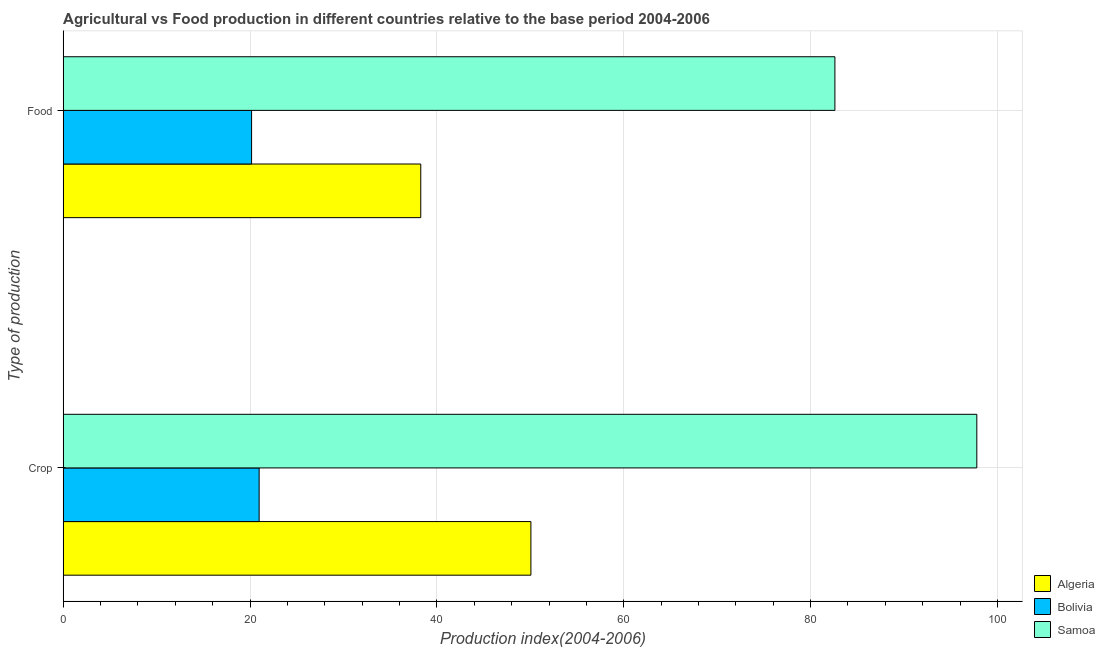How many different coloured bars are there?
Offer a very short reply. 3. How many groups of bars are there?
Your answer should be very brief. 2. Are the number of bars per tick equal to the number of legend labels?
Offer a very short reply. Yes. Are the number of bars on each tick of the Y-axis equal?
Your answer should be compact. Yes. How many bars are there on the 2nd tick from the bottom?
Your answer should be very brief. 3. What is the label of the 1st group of bars from the top?
Offer a very short reply. Food. What is the crop production index in Bolivia?
Provide a succinct answer. 20.97. Across all countries, what is the maximum food production index?
Provide a short and direct response. 82.6. Across all countries, what is the minimum food production index?
Offer a very short reply. 20.16. In which country was the food production index maximum?
Offer a terse response. Samoa. What is the total food production index in the graph?
Offer a very short reply. 141.03. What is the difference between the crop production index in Samoa and that in Bolivia?
Your answer should be compact. 76.82. What is the difference between the crop production index in Algeria and the food production index in Bolivia?
Your response must be concise. 29.9. What is the average food production index per country?
Provide a succinct answer. 47.01. What is the difference between the food production index and crop production index in Bolivia?
Provide a short and direct response. -0.81. What is the ratio of the food production index in Algeria to that in Samoa?
Your response must be concise. 0.46. Is the food production index in Samoa less than that in Algeria?
Offer a terse response. No. In how many countries, is the crop production index greater than the average crop production index taken over all countries?
Give a very brief answer. 1. What does the 1st bar from the top in Crop represents?
Your answer should be very brief. Samoa. What does the 1st bar from the bottom in Crop represents?
Offer a very short reply. Algeria. How many bars are there?
Your response must be concise. 6. How many countries are there in the graph?
Make the answer very short. 3. What is the difference between two consecutive major ticks on the X-axis?
Provide a succinct answer. 20. Where does the legend appear in the graph?
Your answer should be very brief. Bottom right. How many legend labels are there?
Give a very brief answer. 3. What is the title of the graph?
Offer a terse response. Agricultural vs Food production in different countries relative to the base period 2004-2006. Does "Greenland" appear as one of the legend labels in the graph?
Your answer should be very brief. No. What is the label or title of the X-axis?
Provide a short and direct response. Production index(2004-2006). What is the label or title of the Y-axis?
Your answer should be very brief. Type of production. What is the Production index(2004-2006) in Algeria in Crop?
Make the answer very short. 50.06. What is the Production index(2004-2006) of Bolivia in Crop?
Provide a short and direct response. 20.97. What is the Production index(2004-2006) in Samoa in Crop?
Keep it short and to the point. 97.79. What is the Production index(2004-2006) of Algeria in Food?
Your response must be concise. 38.27. What is the Production index(2004-2006) of Bolivia in Food?
Ensure brevity in your answer.  20.16. What is the Production index(2004-2006) of Samoa in Food?
Offer a terse response. 82.6. Across all Type of production, what is the maximum Production index(2004-2006) of Algeria?
Offer a very short reply. 50.06. Across all Type of production, what is the maximum Production index(2004-2006) of Bolivia?
Offer a terse response. 20.97. Across all Type of production, what is the maximum Production index(2004-2006) in Samoa?
Make the answer very short. 97.79. Across all Type of production, what is the minimum Production index(2004-2006) of Algeria?
Your answer should be very brief. 38.27. Across all Type of production, what is the minimum Production index(2004-2006) of Bolivia?
Offer a terse response. 20.16. Across all Type of production, what is the minimum Production index(2004-2006) in Samoa?
Ensure brevity in your answer.  82.6. What is the total Production index(2004-2006) of Algeria in the graph?
Offer a very short reply. 88.33. What is the total Production index(2004-2006) of Bolivia in the graph?
Give a very brief answer. 41.13. What is the total Production index(2004-2006) of Samoa in the graph?
Ensure brevity in your answer.  180.39. What is the difference between the Production index(2004-2006) in Algeria in Crop and that in Food?
Your response must be concise. 11.79. What is the difference between the Production index(2004-2006) of Bolivia in Crop and that in Food?
Ensure brevity in your answer.  0.81. What is the difference between the Production index(2004-2006) of Samoa in Crop and that in Food?
Your answer should be very brief. 15.19. What is the difference between the Production index(2004-2006) of Algeria in Crop and the Production index(2004-2006) of Bolivia in Food?
Make the answer very short. 29.9. What is the difference between the Production index(2004-2006) of Algeria in Crop and the Production index(2004-2006) of Samoa in Food?
Provide a succinct answer. -32.54. What is the difference between the Production index(2004-2006) of Bolivia in Crop and the Production index(2004-2006) of Samoa in Food?
Your answer should be compact. -61.63. What is the average Production index(2004-2006) of Algeria per Type of production?
Keep it short and to the point. 44.16. What is the average Production index(2004-2006) in Bolivia per Type of production?
Your answer should be compact. 20.57. What is the average Production index(2004-2006) of Samoa per Type of production?
Provide a succinct answer. 90.19. What is the difference between the Production index(2004-2006) of Algeria and Production index(2004-2006) of Bolivia in Crop?
Provide a succinct answer. 29.09. What is the difference between the Production index(2004-2006) of Algeria and Production index(2004-2006) of Samoa in Crop?
Keep it short and to the point. -47.73. What is the difference between the Production index(2004-2006) of Bolivia and Production index(2004-2006) of Samoa in Crop?
Make the answer very short. -76.82. What is the difference between the Production index(2004-2006) of Algeria and Production index(2004-2006) of Bolivia in Food?
Make the answer very short. 18.11. What is the difference between the Production index(2004-2006) of Algeria and Production index(2004-2006) of Samoa in Food?
Offer a terse response. -44.33. What is the difference between the Production index(2004-2006) in Bolivia and Production index(2004-2006) in Samoa in Food?
Make the answer very short. -62.44. What is the ratio of the Production index(2004-2006) of Algeria in Crop to that in Food?
Your answer should be very brief. 1.31. What is the ratio of the Production index(2004-2006) in Bolivia in Crop to that in Food?
Your response must be concise. 1.04. What is the ratio of the Production index(2004-2006) in Samoa in Crop to that in Food?
Offer a terse response. 1.18. What is the difference between the highest and the second highest Production index(2004-2006) of Algeria?
Keep it short and to the point. 11.79. What is the difference between the highest and the second highest Production index(2004-2006) in Bolivia?
Your response must be concise. 0.81. What is the difference between the highest and the second highest Production index(2004-2006) of Samoa?
Ensure brevity in your answer.  15.19. What is the difference between the highest and the lowest Production index(2004-2006) in Algeria?
Make the answer very short. 11.79. What is the difference between the highest and the lowest Production index(2004-2006) in Bolivia?
Offer a terse response. 0.81. What is the difference between the highest and the lowest Production index(2004-2006) of Samoa?
Provide a succinct answer. 15.19. 